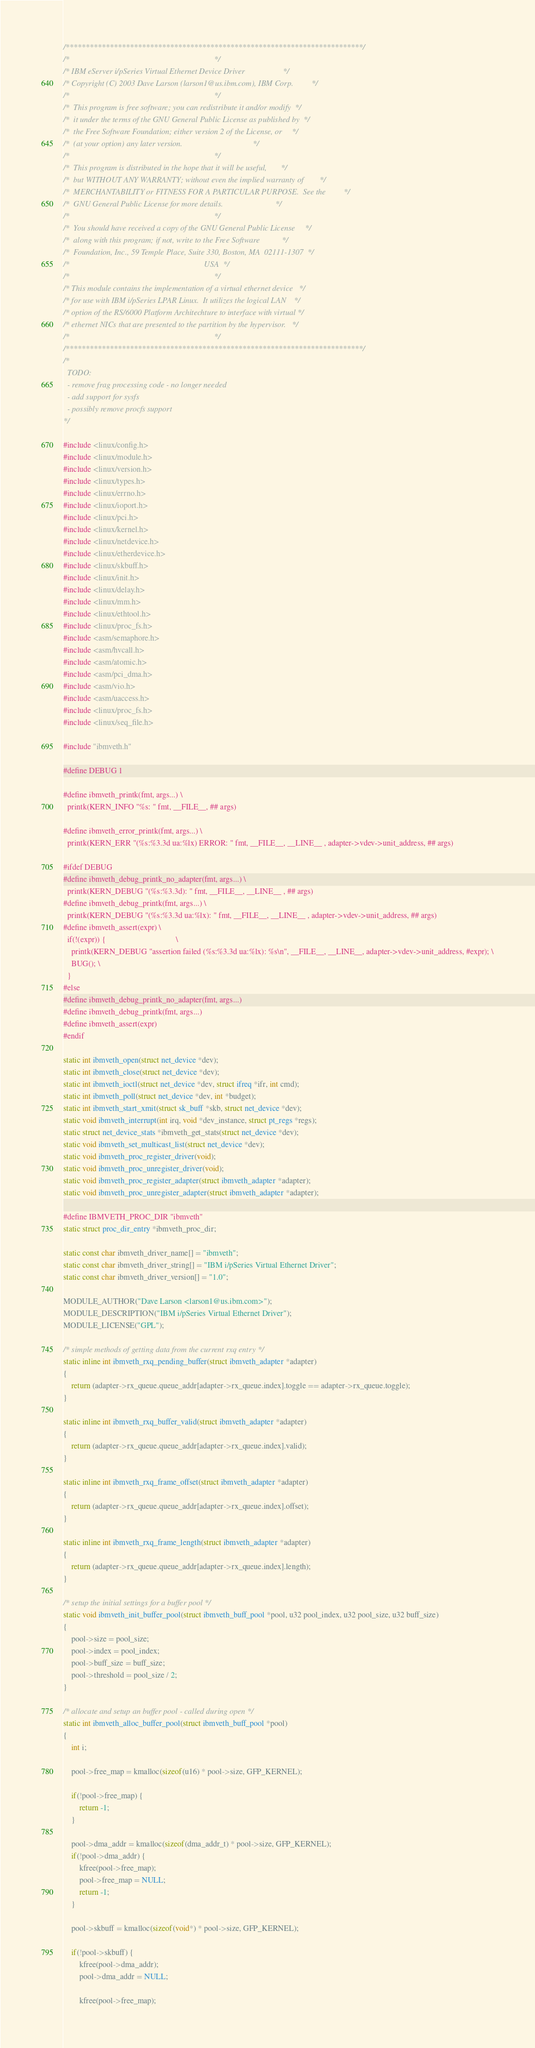<code> <loc_0><loc_0><loc_500><loc_500><_C_>/**************************************************************************/
/*                                                                        */
/* IBM eServer i/pSeries Virtual Ethernet Device Driver                   */
/* Copyright (C) 2003 Dave Larson (larson1@us.ibm.com), IBM Corp.         */
/*                                                                        */
/*  This program is free software; you can redistribute it and/or modify  */
/*  it under the terms of the GNU General Public License as published by  */
/*  the Free Software Foundation; either version 2 of the License, or     */
/*  (at your option) any later version.                                   */
/*                                                                        */
/*  This program is distributed in the hope that it will be useful,       */
/*  but WITHOUT ANY WARRANTY; without even the implied warranty of        */
/*  MERCHANTABILITY or FITNESS FOR A PARTICULAR PURPOSE.  See the         */
/*  GNU General Public License for more details.                          */
/*                                                                        */
/*  You should have received a copy of the GNU General Public License     */
/*  along with this program; if not, write to the Free Software           */
/*  Foundation, Inc., 59 Temple Place, Suite 330, Boston, MA  02111-1307  */
/*                                                                   USA  */
/*                                                                        */
/* This module contains the implementation of a virtual ethernet device   */
/* for use with IBM i/pSeries LPAR Linux.  It utilizes the logical LAN    */
/* option of the RS/6000 Platform Architechture to interface with virtual */
/* ethernet NICs that are presented to the partition by the hypervisor.   */
/*                                                                        */ 
/**************************************************************************/
/*
  TODO:
  - remove frag processing code - no longer needed
  - add support for sysfs
  - possibly remove procfs support
*/

#include <linux/config.h>
#include <linux/module.h>
#include <linux/version.h>
#include <linux/types.h>
#include <linux/errno.h>
#include <linux/ioport.h>
#include <linux/pci.h>
#include <linux/kernel.h>
#include <linux/netdevice.h>
#include <linux/etherdevice.h>
#include <linux/skbuff.h>
#include <linux/init.h>
#include <linux/delay.h>
#include <linux/mm.h>
#include <linux/ethtool.h>
#include <linux/proc_fs.h>
#include <asm/semaphore.h>
#include <asm/hvcall.h>
#include <asm/atomic.h>
#include <asm/pci_dma.h>
#include <asm/vio.h>
#include <asm/uaccess.h>
#include <linux/proc_fs.h>
#include <linux/seq_file.h>

#include "ibmveth.h"

#define DEBUG 1

#define ibmveth_printk(fmt, args...) \
  printk(KERN_INFO "%s: " fmt, __FILE__, ## args)

#define ibmveth_error_printk(fmt, args...) \
  printk(KERN_ERR "(%s:%3.3d ua:%lx) ERROR: " fmt, __FILE__, __LINE__ , adapter->vdev->unit_address, ## args)

#ifdef DEBUG
#define ibmveth_debug_printk_no_adapter(fmt, args...) \
  printk(KERN_DEBUG "(%s:%3.3d): " fmt, __FILE__, __LINE__ , ## args)
#define ibmveth_debug_printk(fmt, args...) \
  printk(KERN_DEBUG "(%s:%3.3d ua:%lx): " fmt, __FILE__, __LINE__ , adapter->vdev->unit_address, ## args)
#define ibmveth_assert(expr) \
  if(!(expr)) {                                   \
    printk(KERN_DEBUG "assertion failed (%s:%3.3d ua:%lx): %s\n", __FILE__, __LINE__, adapter->vdev->unit_address, #expr); \
    BUG(); \
  }
#else
#define ibmveth_debug_printk_no_adapter(fmt, args...)
#define ibmveth_debug_printk(fmt, args...)
#define ibmveth_assert(expr) 
#endif

static int ibmveth_open(struct net_device *dev);
static int ibmveth_close(struct net_device *dev);
static int ibmveth_ioctl(struct net_device *dev, struct ifreq *ifr, int cmd);
static int ibmveth_poll(struct net_device *dev, int *budget);
static int ibmveth_start_xmit(struct sk_buff *skb, struct net_device *dev);
static void ibmveth_interrupt(int irq, void *dev_instance, struct pt_regs *regs);
static struct net_device_stats *ibmveth_get_stats(struct net_device *dev);
static void ibmveth_set_multicast_list(struct net_device *dev);
static void ibmveth_proc_register_driver(void);
static void ibmveth_proc_unregister_driver(void);
static void ibmveth_proc_register_adapter(struct ibmveth_adapter *adapter);
static void ibmveth_proc_unregister_adapter(struct ibmveth_adapter *adapter);

#define IBMVETH_PROC_DIR "ibmveth"
static struct proc_dir_entry *ibmveth_proc_dir;

static const char ibmveth_driver_name[] = "ibmveth";
static const char ibmveth_driver_string[] = "IBM i/pSeries Virtual Ethernet Driver";
static const char ibmveth_driver_version[] = "1.0";

MODULE_AUTHOR("Dave Larson <larson1@us.ibm.com>");
MODULE_DESCRIPTION("IBM i/pSeries Virtual Ethernet Driver");
MODULE_LICENSE("GPL");

/* simple methods of getting data from the current rxq entry */
static inline int ibmveth_rxq_pending_buffer(struct ibmveth_adapter *adapter)
{
	return (adapter->rx_queue.queue_addr[adapter->rx_queue.index].toggle == adapter->rx_queue.toggle);
}

static inline int ibmveth_rxq_buffer_valid(struct ibmveth_adapter *adapter)
{
	return (adapter->rx_queue.queue_addr[adapter->rx_queue.index].valid);
}

static inline int ibmveth_rxq_frame_offset(struct ibmveth_adapter *adapter)
{
	return (adapter->rx_queue.queue_addr[adapter->rx_queue.index].offset);
}

static inline int ibmveth_rxq_frame_length(struct ibmveth_adapter *adapter)
{
	return (adapter->rx_queue.queue_addr[adapter->rx_queue.index].length);
}

/* setup the initial settings for a buffer pool */
static void ibmveth_init_buffer_pool(struct ibmveth_buff_pool *pool, u32 pool_index, u32 pool_size, u32 buff_size)
{
	pool->size = pool_size;
	pool->index = pool_index;
	pool->buff_size = buff_size;
	pool->threshold = pool_size / 2;
}

/* allocate and setup an buffer pool - called during open */
static int ibmveth_alloc_buffer_pool(struct ibmveth_buff_pool *pool)
{
	int i;

	pool->free_map = kmalloc(sizeof(u16) * pool->size, GFP_KERNEL); 

	if(!pool->free_map) {
		return -1;
	}

	pool->dma_addr = kmalloc(sizeof(dma_addr_t) * pool->size, GFP_KERNEL); 
	if(!pool->dma_addr) {
		kfree(pool->free_map);
		pool->free_map = NULL;
		return -1;
	}

	pool->skbuff = kmalloc(sizeof(void*) * pool->size, GFP_KERNEL);

	if(!pool->skbuff) {
		kfree(pool->dma_addr);
		pool->dma_addr = NULL;

		kfree(pool->free_map);</code> 